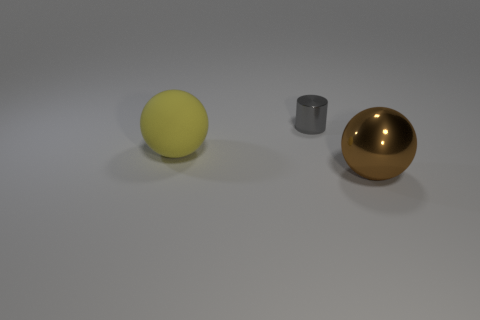Add 3 gray metal things. How many objects exist? 6 Subtract all cylinders. How many objects are left? 2 Subtract 0 blue spheres. How many objects are left? 3 Subtract all green spheres. Subtract all red cylinders. How many spheres are left? 2 Subtract all tiny gray rubber spheres. Subtract all small things. How many objects are left? 2 Add 1 small gray metal objects. How many small gray metal objects are left? 2 Add 2 purple metallic spheres. How many purple metallic spheres exist? 2 